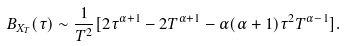Convert formula to latex. <formula><loc_0><loc_0><loc_500><loc_500>B _ { X _ { T } } ( \tau ) \sim \frac { 1 } { T ^ { 2 } } [ 2 \tau ^ { \alpha + 1 } - 2 T ^ { \alpha + 1 } - \alpha ( \alpha + 1 ) \tau ^ { 2 } T ^ { \alpha - 1 } ] .</formula> 